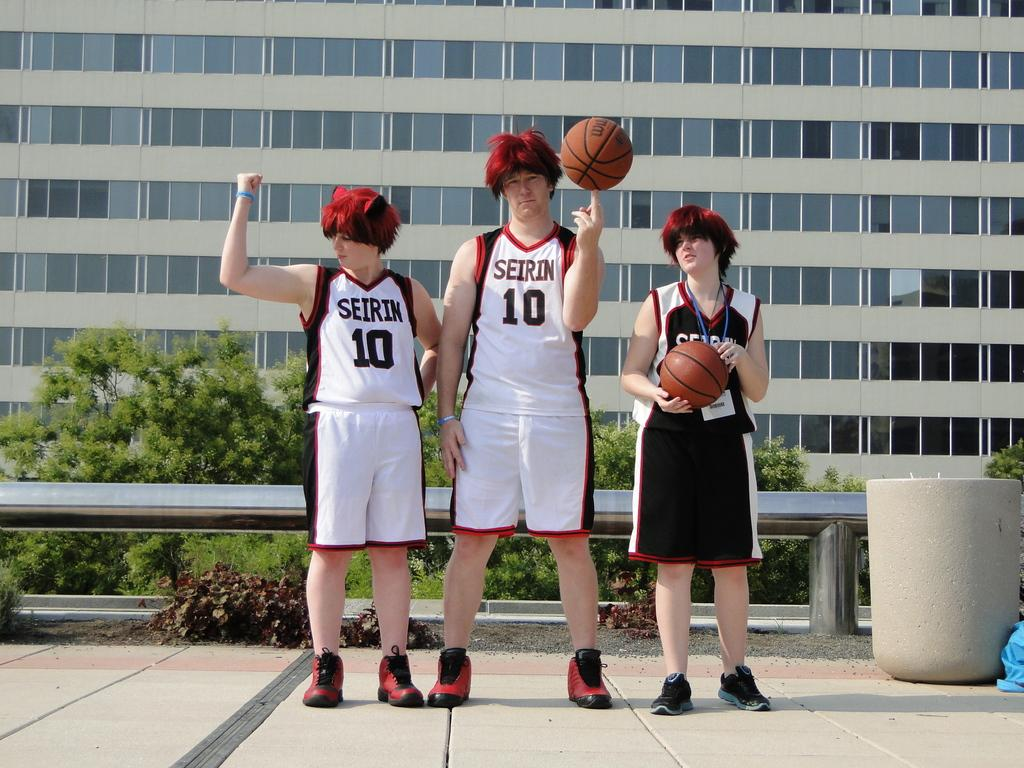Provide a one-sentence caption for the provided image. Three people in red wigs and basketball clothes for the Seirin team in front of a building. 